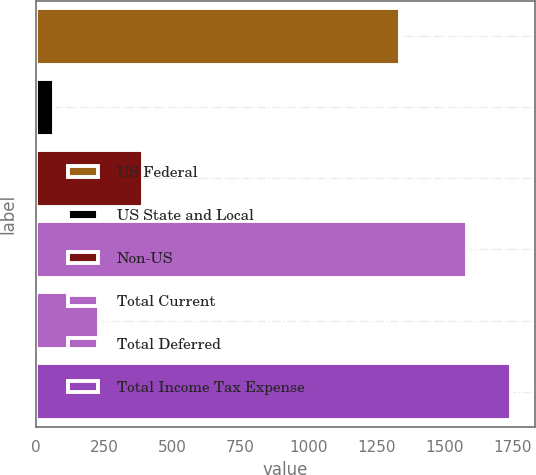<chart> <loc_0><loc_0><loc_500><loc_500><bar_chart><fcel>US Federal<fcel>US State and Local<fcel>Non-US<fcel>Total Current<fcel>Total Deferred<fcel>Total Income Tax Expense<nl><fcel>1338<fcel>67<fcel>394.6<fcel>1582<fcel>230.8<fcel>1745.8<nl></chart> 